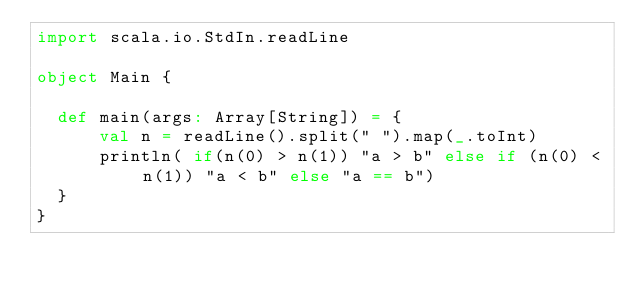<code> <loc_0><loc_0><loc_500><loc_500><_Scala_>import scala.io.StdIn.readLine

object Main {

  def main(args: Array[String]) = {
      val n = readLine().split(" ").map(_.toInt)
      println( if(n(0) > n(1)) "a > b" else if (n(0) < n(1)) "a < b" else "a == b")
  }
}</code> 